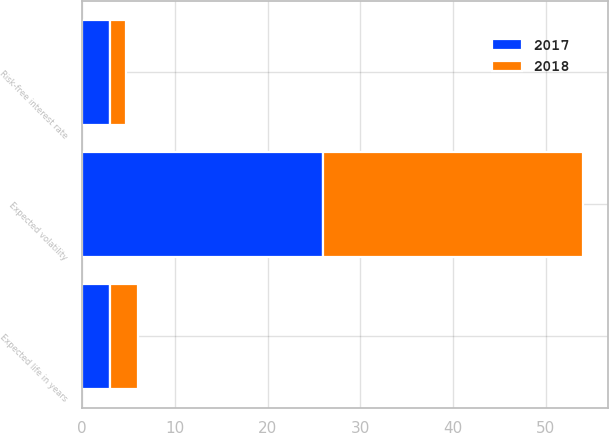Convert chart. <chart><loc_0><loc_0><loc_500><loc_500><stacked_bar_chart><ecel><fcel>Risk-free interest rate<fcel>Expected life in years<fcel>Expected volatility<nl><fcel>2017<fcel>3.03<fcel>3<fcel>26<nl><fcel>2018<fcel>1.73<fcel>3<fcel>28<nl></chart> 